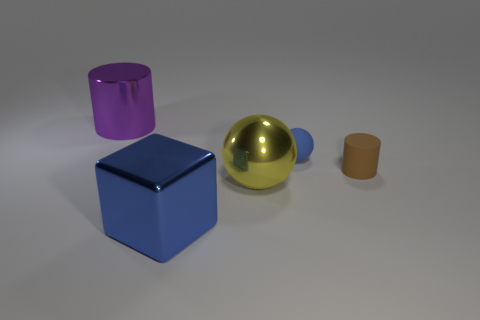The rubber thing that is behind the cylinder that is to the right of the purple thing is what shape?
Provide a succinct answer. Sphere. What is the shape of the large purple object that is the same material as the yellow sphere?
Provide a short and direct response. Cylinder. How many other things are the same shape as the blue metal object?
Provide a short and direct response. 0. Is the size of the blue thing behind the brown object the same as the metal block?
Offer a very short reply. No. Are there more big purple metallic objects in front of the brown rubber thing than large shiny blocks?
Give a very brief answer. No. There is a tiny thing that is in front of the tiny blue sphere; how many blue rubber balls are in front of it?
Provide a short and direct response. 0. Are there fewer blue matte spheres right of the blue metallic block than small yellow cubes?
Make the answer very short. No. There is a object that is to the left of the blue object in front of the large yellow shiny thing; are there any blue matte balls that are right of it?
Ensure brevity in your answer.  Yes. Do the purple cylinder and the blue object that is in front of the brown rubber thing have the same material?
Your answer should be very brief. Yes. What is the color of the rubber object right of the blue thing on the right side of the yellow object?
Make the answer very short. Brown. 